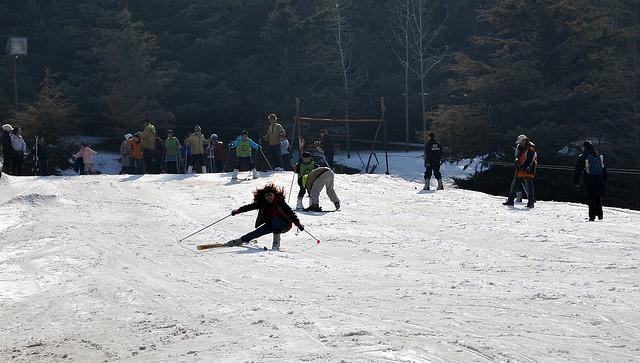Is it cold?
Keep it brief. Yes. What is the woman doing?
Keep it brief. Skiing. Is it daytime?
Short answer required. Yes. 